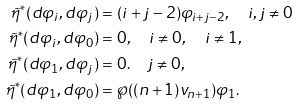<formula> <loc_0><loc_0><loc_500><loc_500>\tilde { \eta } ^ { * } ( d \varphi _ { i } , d \varphi _ { j } ) & = ( i + j - 2 ) \varphi _ { i + j - 2 } , \quad i , j \neq 0 \\ \tilde { \eta } ^ { * } ( d \varphi _ { i } , d \varphi _ { 0 } ) & = 0 , \quad i \neq 0 , \quad i \neq 1 , \\ \tilde { \eta } ^ { * } ( d \varphi _ { 1 } , d \varphi _ { j } ) & = 0 . \quad j \neq 0 , \\ \tilde { \eta } ^ { * } ( d \varphi _ { 1 } , d \varphi _ { 0 } ) & = \wp ( ( n + 1 ) v _ { n + 1 } ) \varphi _ { 1 } . \\</formula> 